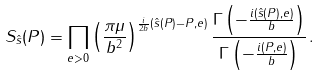<formula> <loc_0><loc_0><loc_500><loc_500>S _ { \hat { s } } ( P ) = \prod _ { e > 0 } \left ( \frac { \pi \mu } { b ^ { 2 } } \right ) ^ { \frac { i } { 2 b } ( \hat { s } ( P ) - P , e ) } \frac { \Gamma \left ( - \frac { i ( \hat { s } ( P ) , e ) } { b } \right ) } { \Gamma \left ( - \frac { i ( P , e ) } { b } \right ) } \, .</formula> 